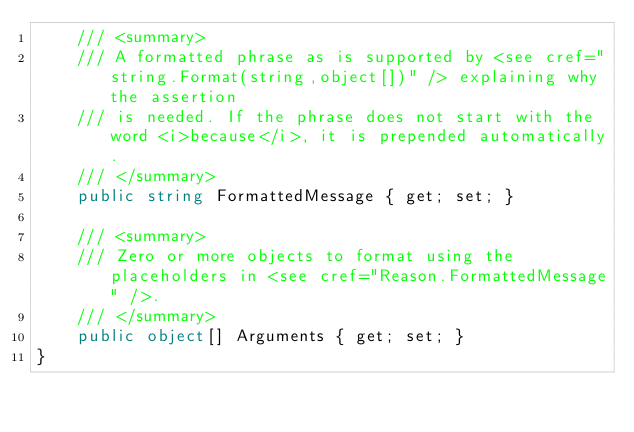<code> <loc_0><loc_0><loc_500><loc_500><_C#_>    /// <summary>
    /// A formatted phrase as is supported by <see cref="string.Format(string,object[])" /> explaining why the assertion
    /// is needed. If the phrase does not start with the word <i>because</i>, it is prepended automatically.
    /// </summary>
    public string FormattedMessage { get; set; }

    /// <summary>
    /// Zero or more objects to format using the placeholders in <see cref="Reason.FormattedMessage" />.
    /// </summary>
    public object[] Arguments { get; set; }
}
</code> 